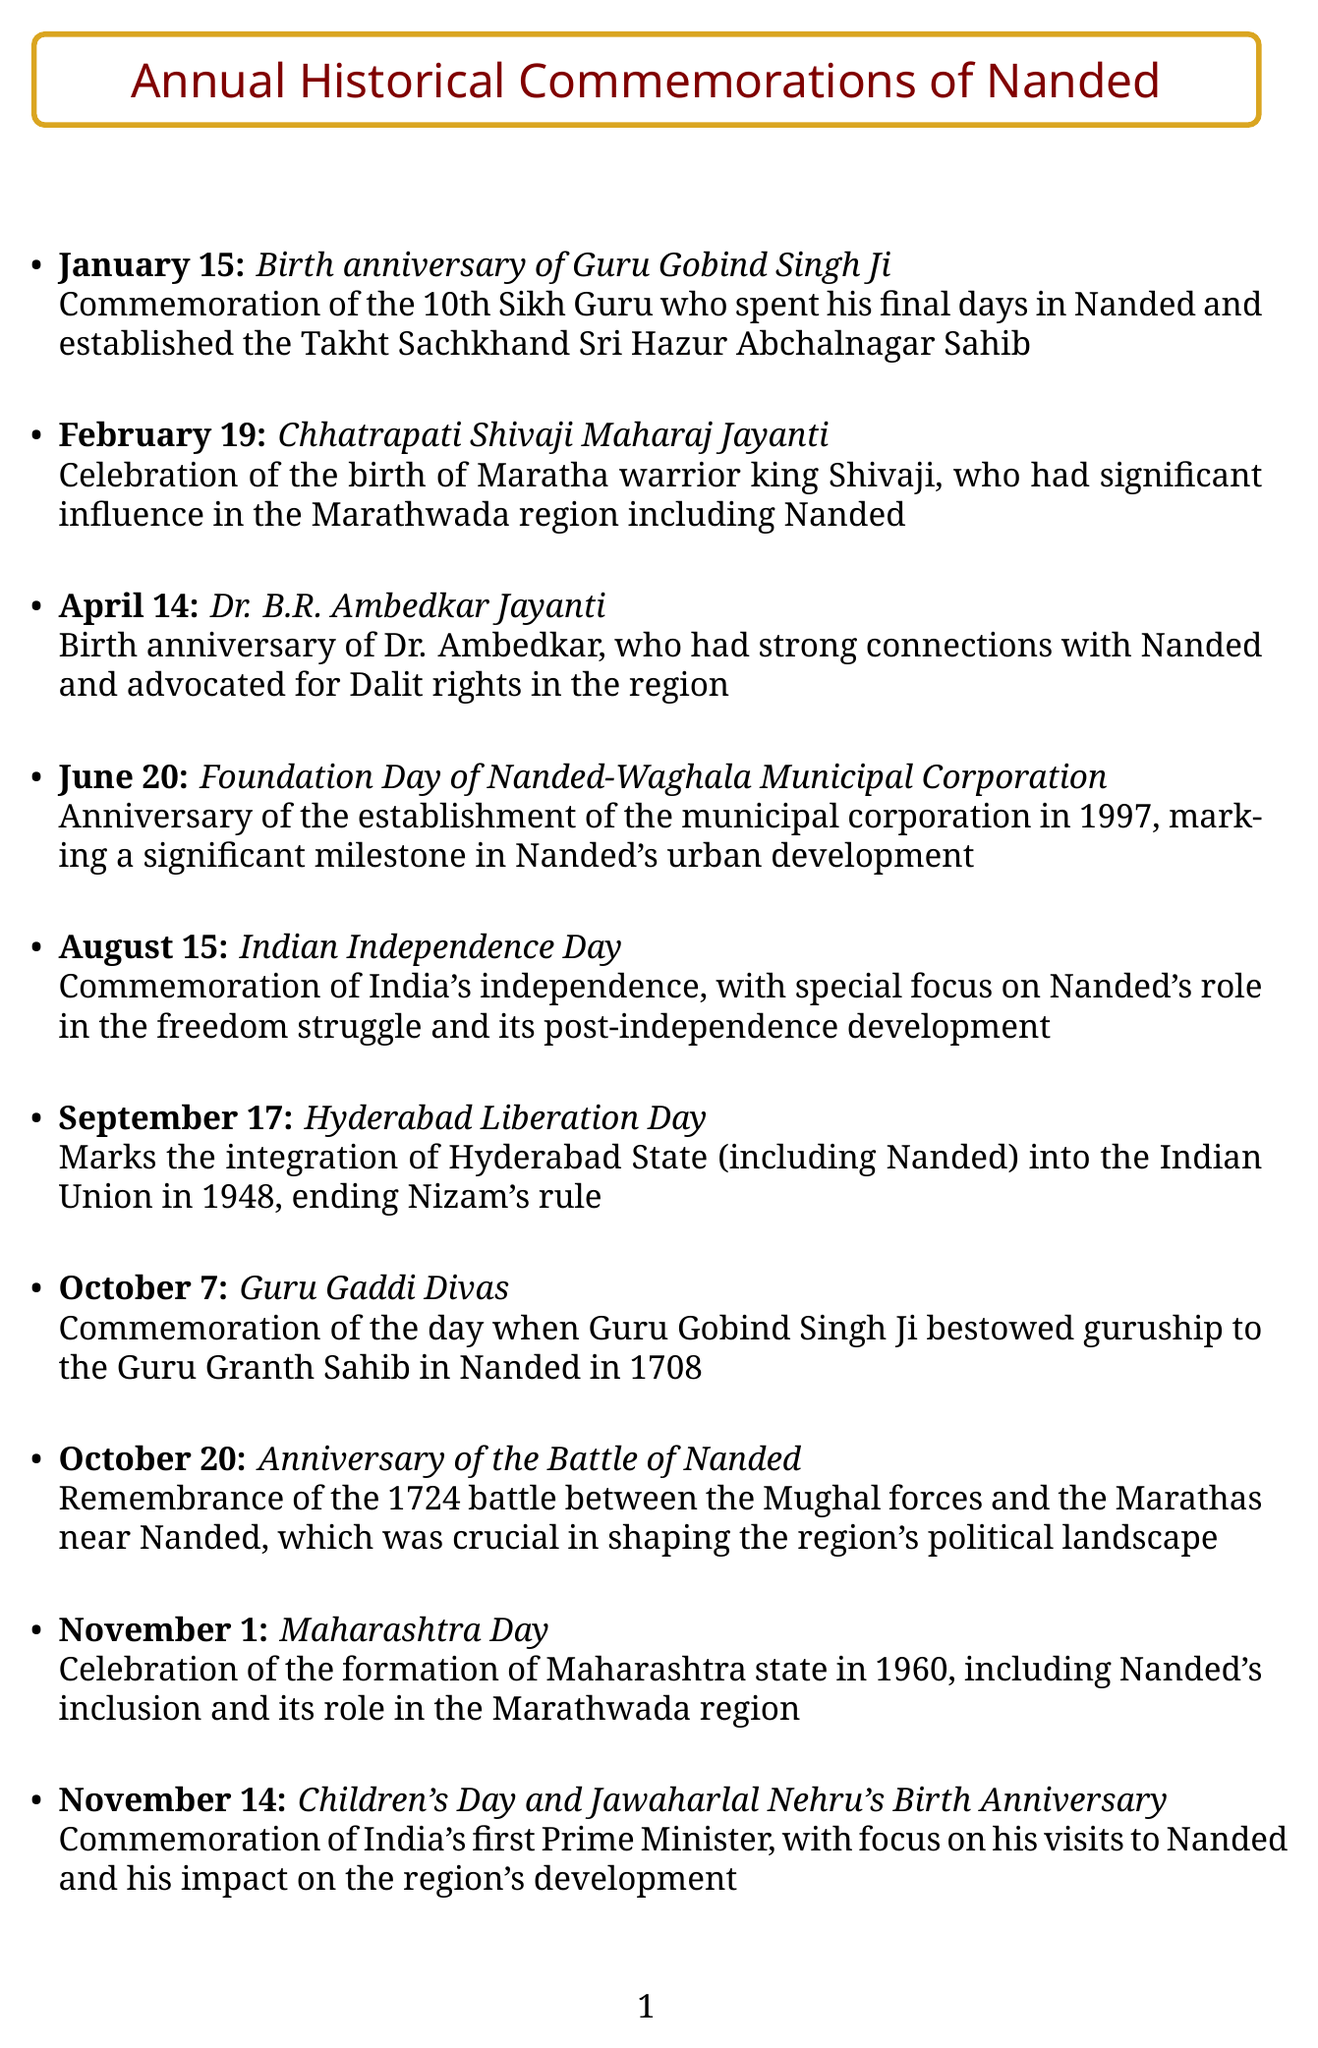what event is commemorated on January 15? The document states that January 15 is the birth anniversary of Guru Gobind Singh Ji.
Answer: birth anniversary of Guru Gobind Singh Ji which important day is celebrated on August 15? According to the document, August 15 is recognized as Indian Independence Day.
Answer: Indian Independence Day how many significant anniversaries are listed for December? The document mentions two important anniversaries in December: Dr. B.R. Ambedkar Death Anniversary and National Mathematics Day.
Answer: 2 what does the event on October 20 commemorate? The document explains that October 20 is the anniversary of the Battle of Nanded.
Answer: anniversary of the Battle of Nanded which influential leader's birth anniversary is observed on April 14? April 14 is celebrated as Dr. B.R. Ambedkar Jayanti, honoring his birth.
Answer: Dr. B.R. Ambedkar what significant historical integration is marked on September 17? The document indicates that September 17 marks Hyderabad Liberation Day, which involves the integration of Hyderabad State into the Indian Union.
Answer: Hyderabad Liberation Day when was the Nanded-Waghala Municipal Corporation founded? The document cites June 20 as the Foundation Day of Nanded-Waghala Municipal Corporation, established in 1997.
Answer: 1997 what anniversary is noted on November 1? The document highlights that November 1 is Maharashtra Day, celebrating the formation of the state.
Answer: Maharashtra Day who is commemorated on November 14 along with Children's Day? The document states that November 14 honors Jawaharlal Nehru's Birth Anniversary.
Answer: Jawaharlal Nehru's Birth Anniversary 